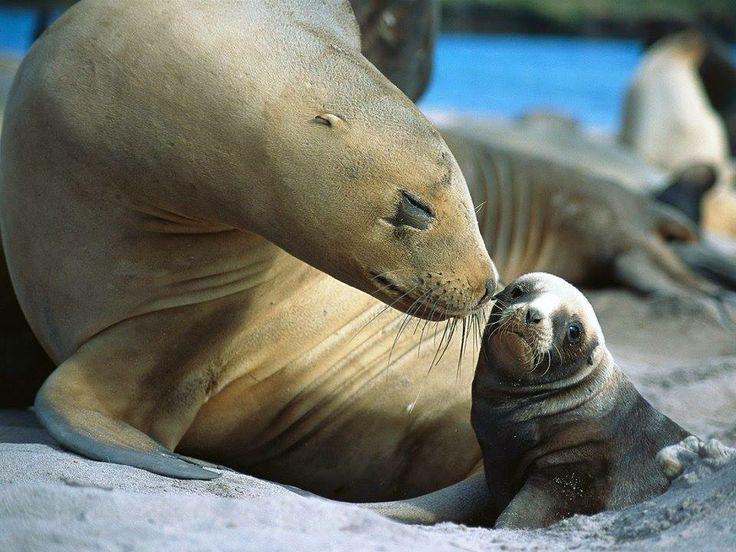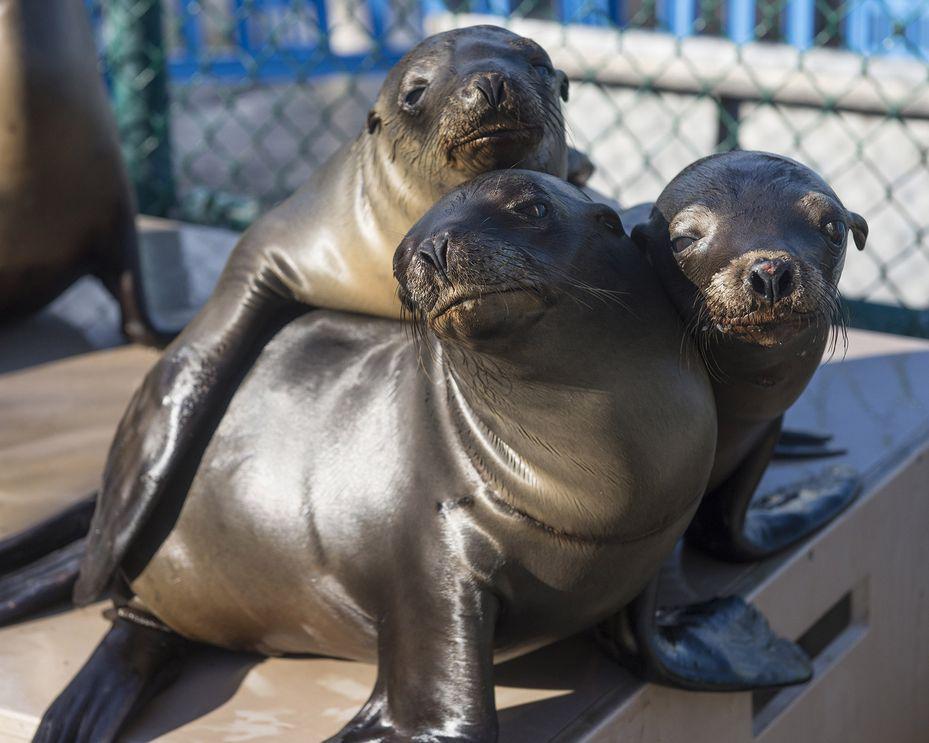The first image is the image on the left, the second image is the image on the right. For the images shown, is this caption "One image shows exactly three seals clustered together, in the foreground." true? Answer yes or no. Yes. 